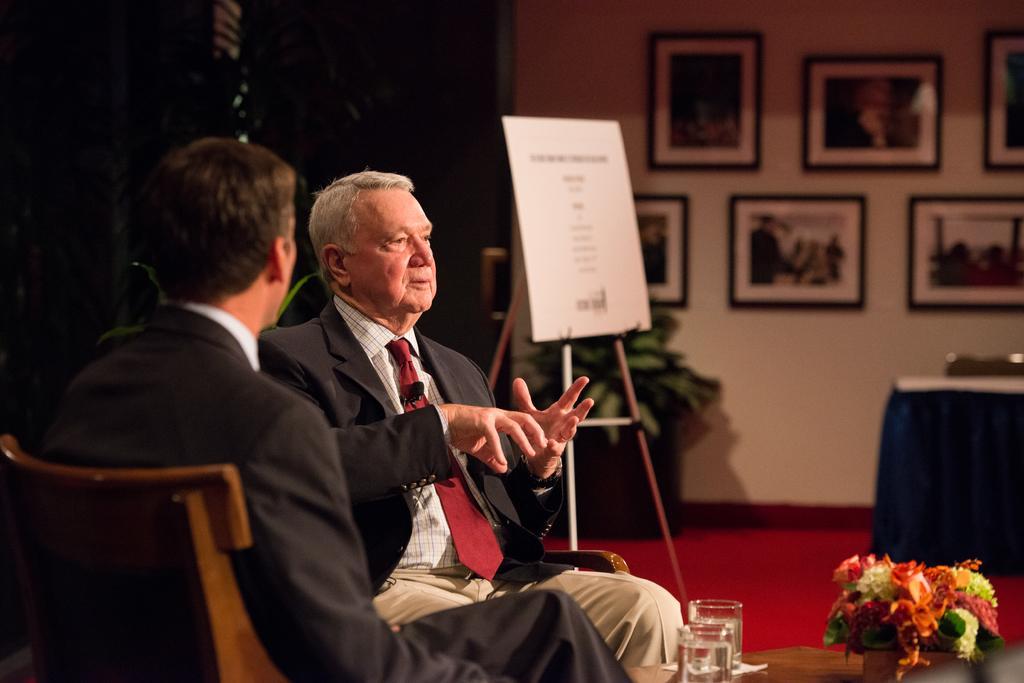Could you give a brief overview of what you see in this image? This image is taken in a room. In this room there are two persons. In the left side of the image a person is sitting on a chair. In the middle of the image a person is sitting on a chair and talking. In the right side of the there is a table with a glass of water and a flower vase. In the middle of the image there is house plant with a pot and a board with a text. In this image there is a wall with few photo frames. 